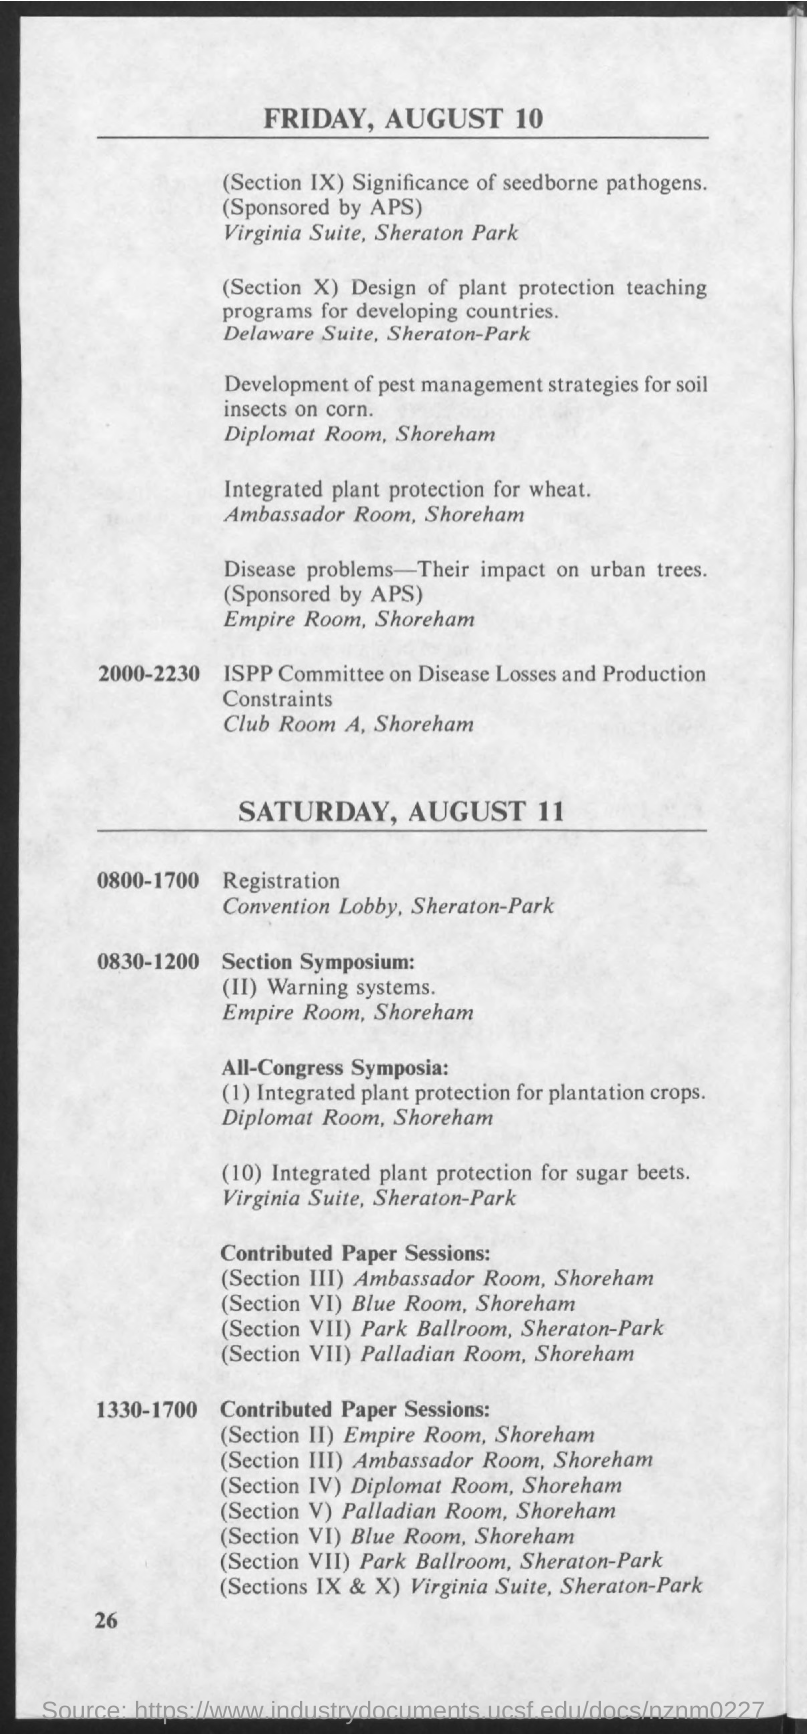Mention a couple of crucial points in this snapshot. The first date mentioned in the document is Friday, August 10. The second date mentioned in the document is Saturday, August 11. 